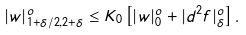Convert formula to latex. <formula><loc_0><loc_0><loc_500><loc_500>| w | ^ { o } _ { 1 + \delta / 2 , 2 + \delta } \leq K _ { 0 } \left [ | w | ^ { o } _ { 0 } + | d ^ { 2 } f | ^ { o } _ { \delta } \right ] .</formula> 